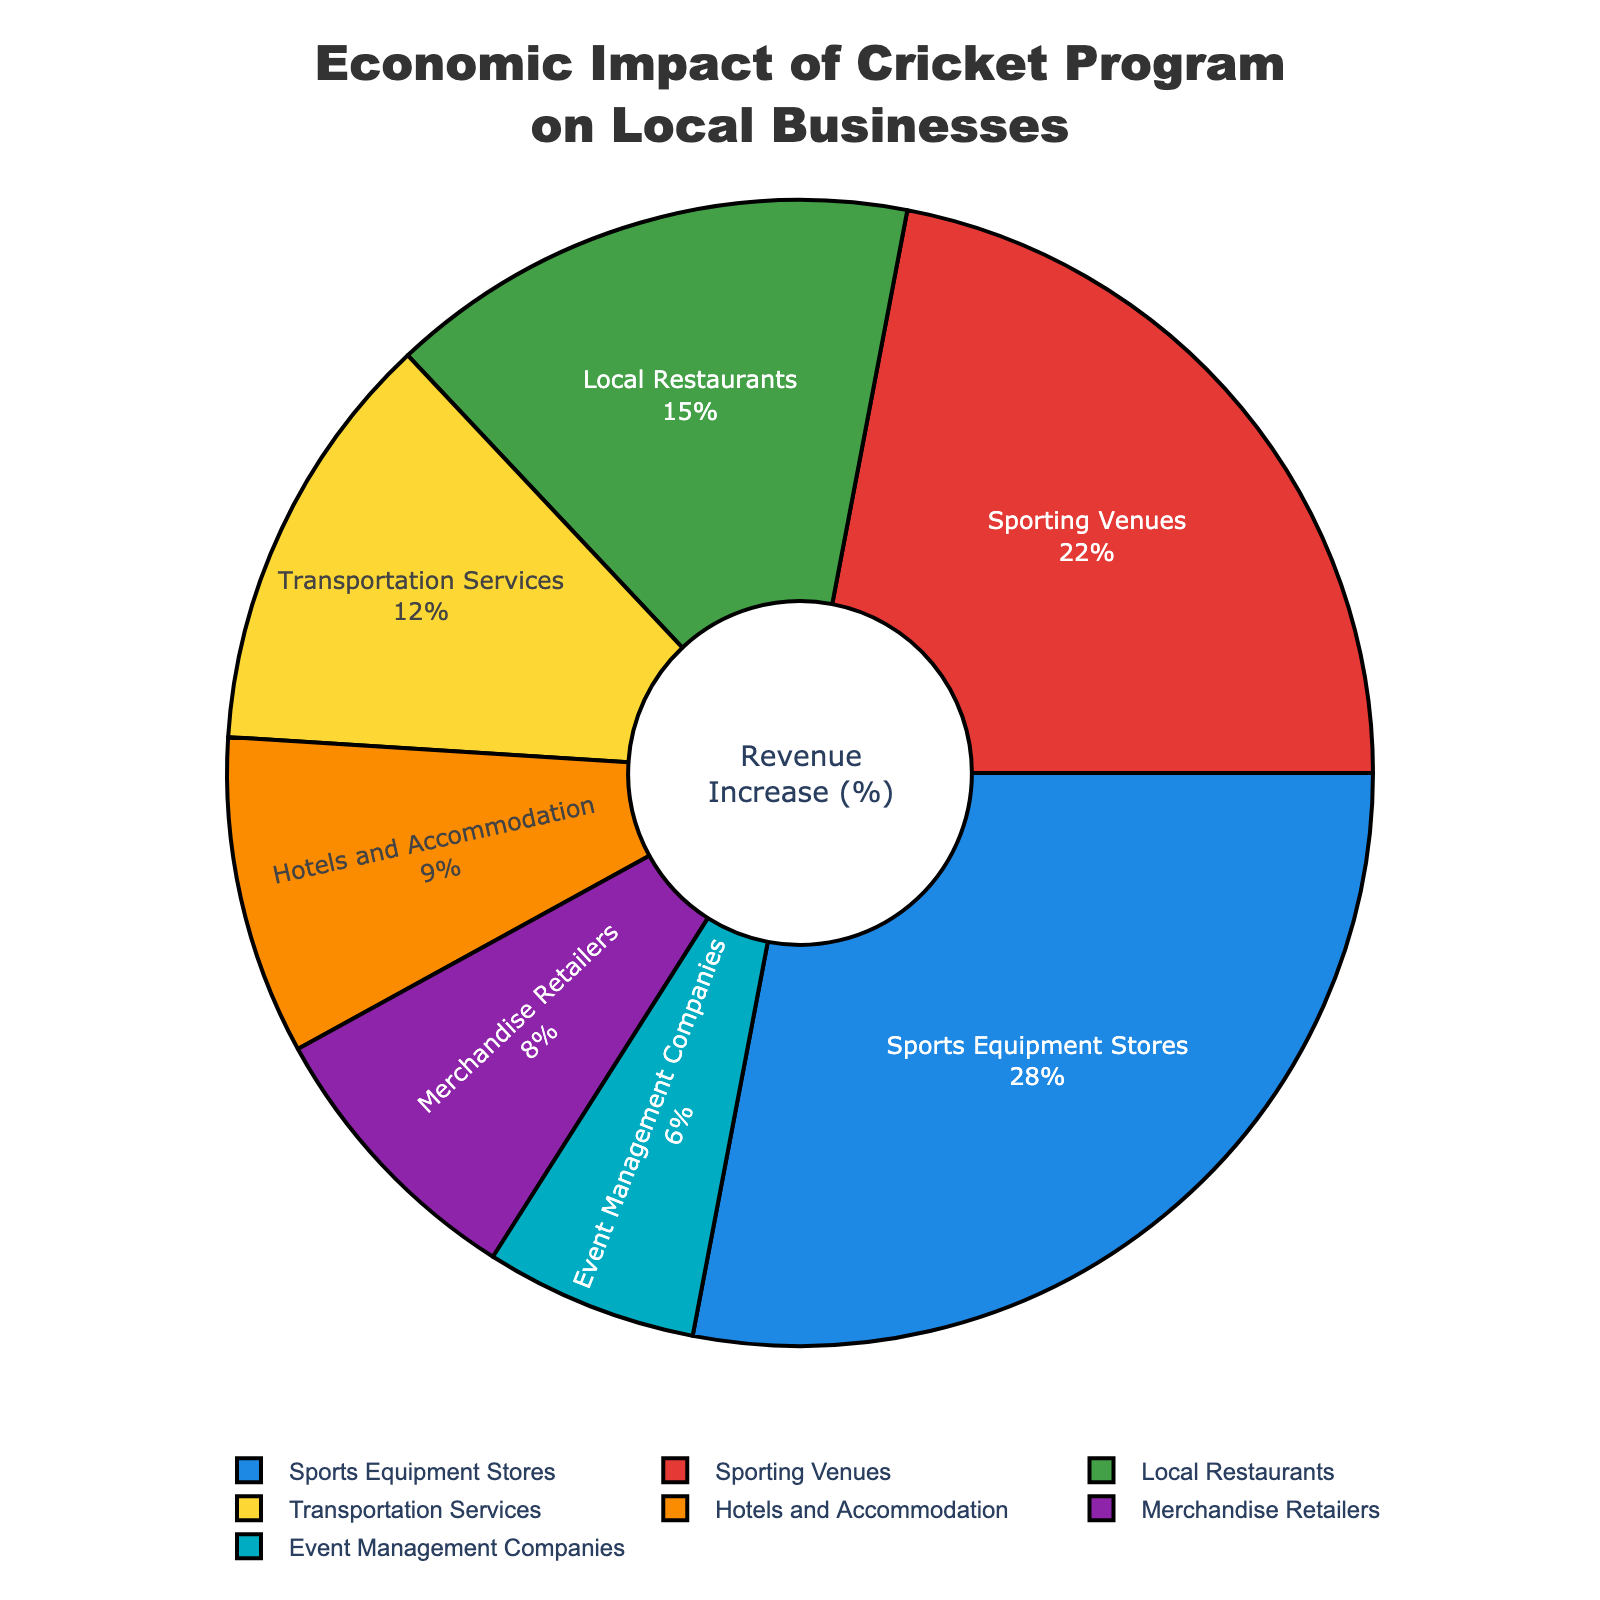Which category shows the highest revenue increase percentage? To find this, look at the segment with the largest percentage in the pie chart. "Sports Equipment Stores" has the highest revenue increase at 28%.
Answer: Sports Equipment Stores Which category has the smallest impact on revenue increase? Look for the segment with the smallest percentage. "Event Management Companies" has the smallest revenue increase at 6%.
Answer: Event Management Companies What is the combined revenue increase percentage of Local Restaurants and Transportation Services? Add the percentages of Local Restaurants (15%) and Transportation Services (12%). 15 + 12 = 27
Answer: 27 Which categories together contribute nearly half of the total revenue increase? Find categories whose percentages sum to around 50%. "Sports Equipment Stores" (28%) and "Sporting Venues" (22%) together sum to 50%.
Answer: Sports Equipment Stores and Sporting Venues How much larger is the percentage increase for Sporting Venues compared to Hotels and Accommodation? Subtract the percentage of Hotels and Accommodation (9%) from Sporting Venues (22%). 22 - 9 = 13
Answer: 13 Which category has a greater revenue increase, Merchandise Retailers or Event Management Companies? Compare the percentages of Merchandise Retailers (8%) and Event Management Companies (6%). Merchandise Retailers have a greater increase at 8%.
Answer: Merchandise Retailers If the categories were ranked by revenue increase, what would be the rank of local restaurants? Rank the percentages: 28, 22, 15, 12, 9, 8, 6. Local Restaurants, with 15%, are third.
Answer: Third What percentage of the total revenue increase do Transportation Services and Sporting Venues together account for? Add the percentages of Transportation Services (12%) and Sporting Venues (22%). 12 + 22 = 34
Answer: 34 Does the category with the highest revenue increase have more than three times the impact of the category with the lowest revenue increase? Divide the highest percentage (28% from Sports Equipment Stores) by the lowest percentage (6% from Event Management Companies). 28 / 6 = 4.67, which is greater than 3 times.
Answer: Yes 